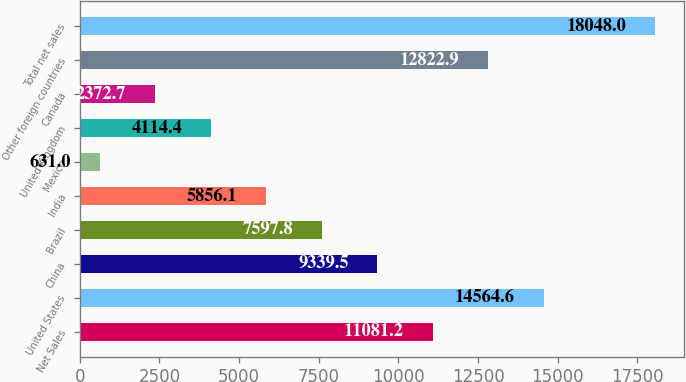Convert chart. <chart><loc_0><loc_0><loc_500><loc_500><bar_chart><fcel>Net Sales<fcel>United States<fcel>China<fcel>Brazil<fcel>India<fcel>Mexico<fcel>United Kingdom<fcel>Canada<fcel>Other foreign countries<fcel>Total net sales<nl><fcel>11081.2<fcel>14564.6<fcel>9339.5<fcel>7597.8<fcel>5856.1<fcel>631<fcel>4114.4<fcel>2372.7<fcel>12822.9<fcel>18048<nl></chart> 